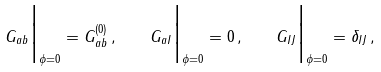<formula> <loc_0><loc_0><loc_500><loc_500>G _ { a b } \Big | _ { \phi = 0 } = G _ { a b } ^ { ( 0 ) } \, , \quad G _ { a I } \Big | _ { \phi = 0 } = 0 \, , \quad G _ { I J } \Big | _ { \phi = 0 } = \delta _ { I J } \, ,</formula> 